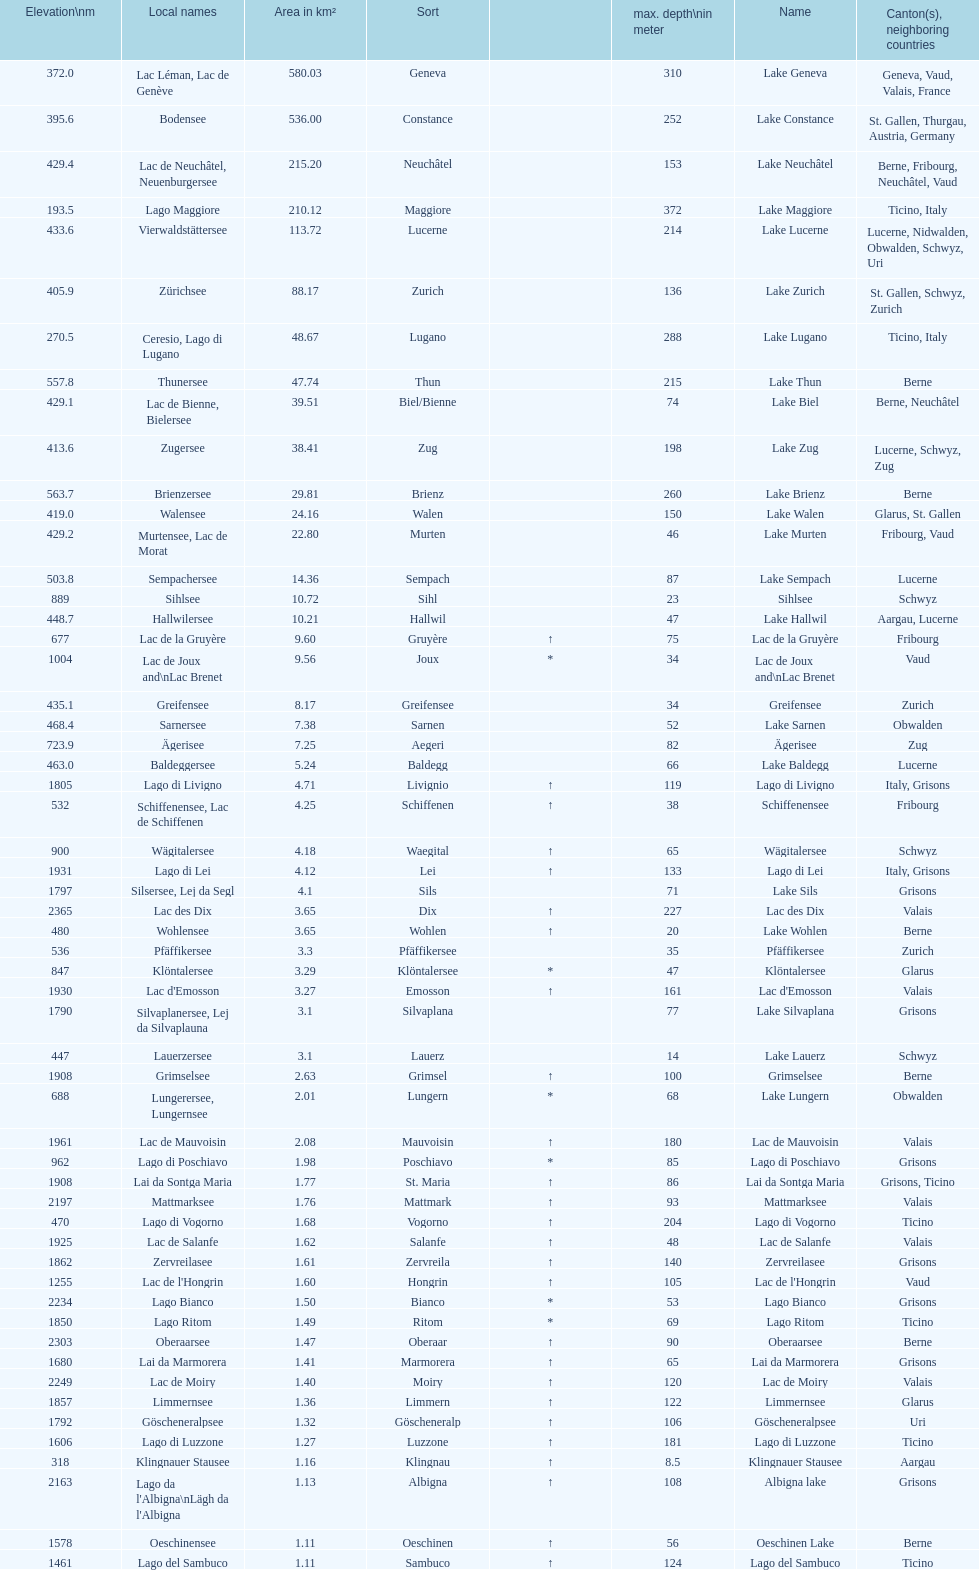How many lakes possess an area under 100 km squared? 51. 